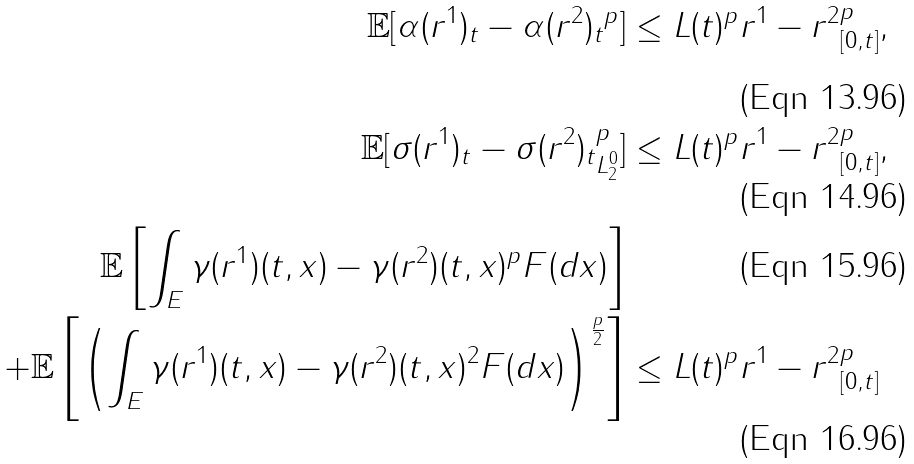<formula> <loc_0><loc_0><loc_500><loc_500>\mathbb { E } [ \| \alpha ( r ^ { 1 } ) _ { t } - \alpha ( r ^ { 2 } ) _ { t } \| ^ { p } ] & \leq L ( t ) ^ { p } \| r ^ { 1 } - r ^ { 2 } \| _ { [ 0 , t ] } ^ { p } , \\ \mathbb { E } [ \| \sigma ( r ^ { 1 } ) _ { t } - \sigma ( r ^ { 2 } ) _ { t } \| _ { L _ { 2 } ^ { 0 } } ^ { p } ] & \leq L ( t ) ^ { p } \| r ^ { 1 } - r ^ { 2 } \| _ { [ 0 , t ] } ^ { p } , \\ \mathbb { E } \left [ \int _ { E } \| \gamma ( r ^ { 1 } ) ( t , x ) - \gamma ( r ^ { 2 } ) ( t , x ) \| ^ { p } F ( d x ) \right ] & \\ + \mathbb { E } \left [ \left ( \int _ { E } \| \gamma ( r ^ { 1 } ) ( t , x ) - \gamma ( r ^ { 2 } ) ( t , x ) \| ^ { 2 } F ( d x ) \right ) ^ { \frac { p } { 2 } } \right ] & \leq L ( t ) ^ { p } \| r ^ { 1 } - r ^ { 2 } \| _ { [ 0 , t ] } ^ { p }</formula> 